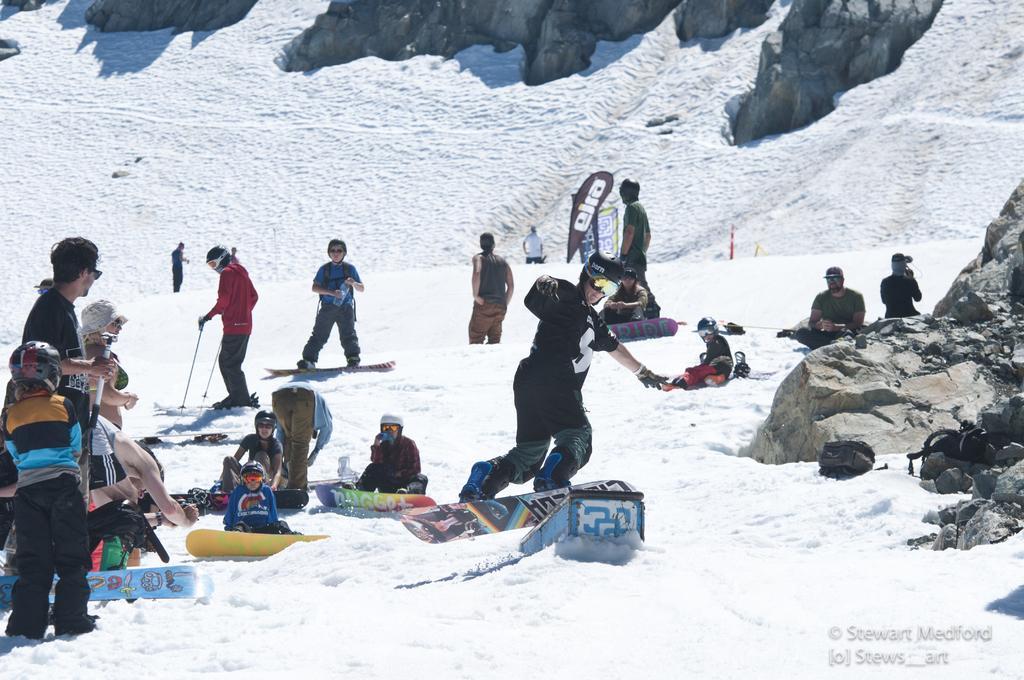Could you give a brief overview of what you see in this image? In this image there are many people. Few are sitting on the ground few are skiing. In the background there are hills. On the ground there is snow. 